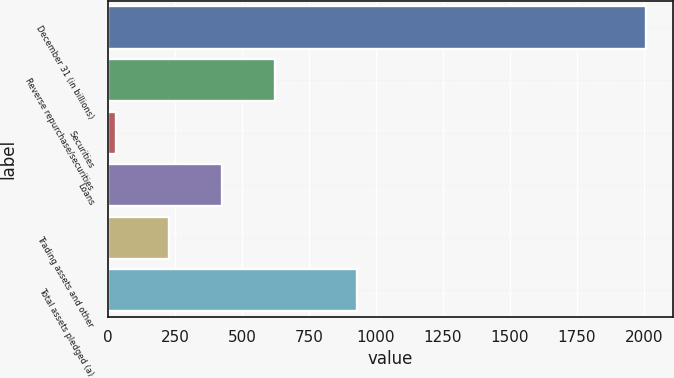<chart> <loc_0><loc_0><loc_500><loc_500><bar_chart><fcel>December 31 (in billions)<fcel>Reverse repurchase/securities<fcel>Securities<fcel>Loans<fcel>Trading assets and other<fcel>Total assets pledged (a)<nl><fcel>2008<fcel>624.1<fcel>31<fcel>426.4<fcel>228.7<fcel>927.9<nl></chart> 